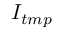<formula> <loc_0><loc_0><loc_500><loc_500>I _ { t m p }</formula> 